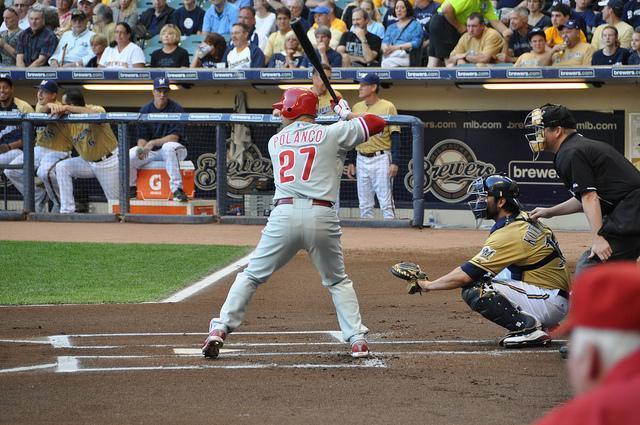How many people can you see?
Give a very brief answer. 8. 